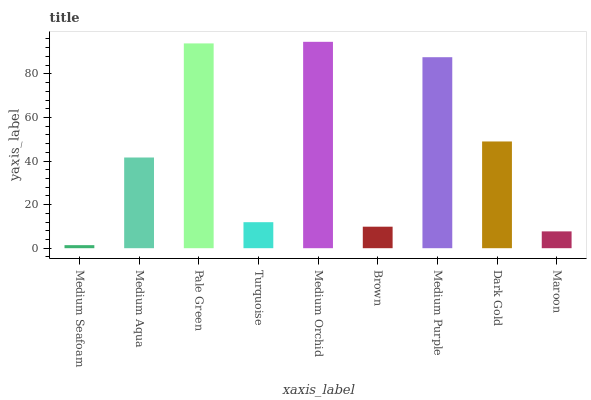Is Medium Seafoam the minimum?
Answer yes or no. Yes. Is Medium Orchid the maximum?
Answer yes or no. Yes. Is Medium Aqua the minimum?
Answer yes or no. No. Is Medium Aqua the maximum?
Answer yes or no. No. Is Medium Aqua greater than Medium Seafoam?
Answer yes or no. Yes. Is Medium Seafoam less than Medium Aqua?
Answer yes or no. Yes. Is Medium Seafoam greater than Medium Aqua?
Answer yes or no. No. Is Medium Aqua less than Medium Seafoam?
Answer yes or no. No. Is Medium Aqua the high median?
Answer yes or no. Yes. Is Medium Aqua the low median?
Answer yes or no. Yes. Is Maroon the high median?
Answer yes or no. No. Is Pale Green the low median?
Answer yes or no. No. 